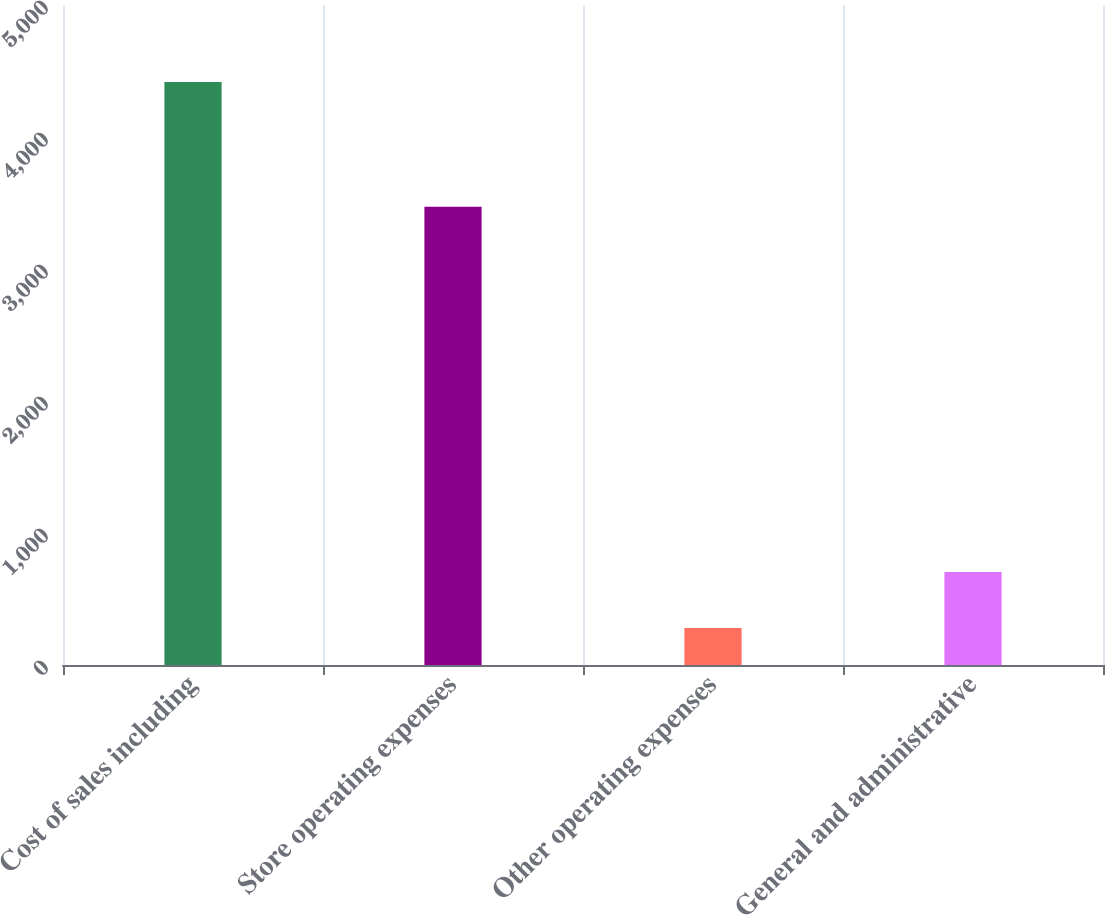Convert chart. <chart><loc_0><loc_0><loc_500><loc_500><bar_chart><fcel>Cost of sales including<fcel>Store operating expenses<fcel>Other operating expenses<fcel>General and administrative<nl><fcel>4416.5<fcel>3471.9<fcel>279.7<fcel>704.6<nl></chart> 